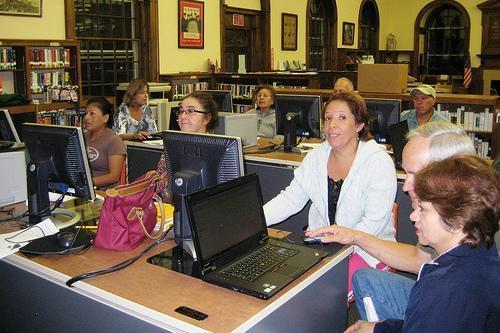How many pairs of glasses are in the picture?
Give a very brief answer. 1. How many laptop computers are there?
Give a very brief answer. 1. 